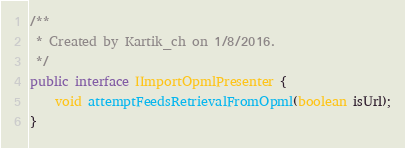Convert code to text. <code><loc_0><loc_0><loc_500><loc_500><_Java_>/**
 * Created by Kartik_ch on 1/8/2016.
 */
public interface IImportOpmlPresenter {
    void attemptFeedsRetrievalFromOpml(boolean isUrl);
}
</code> 